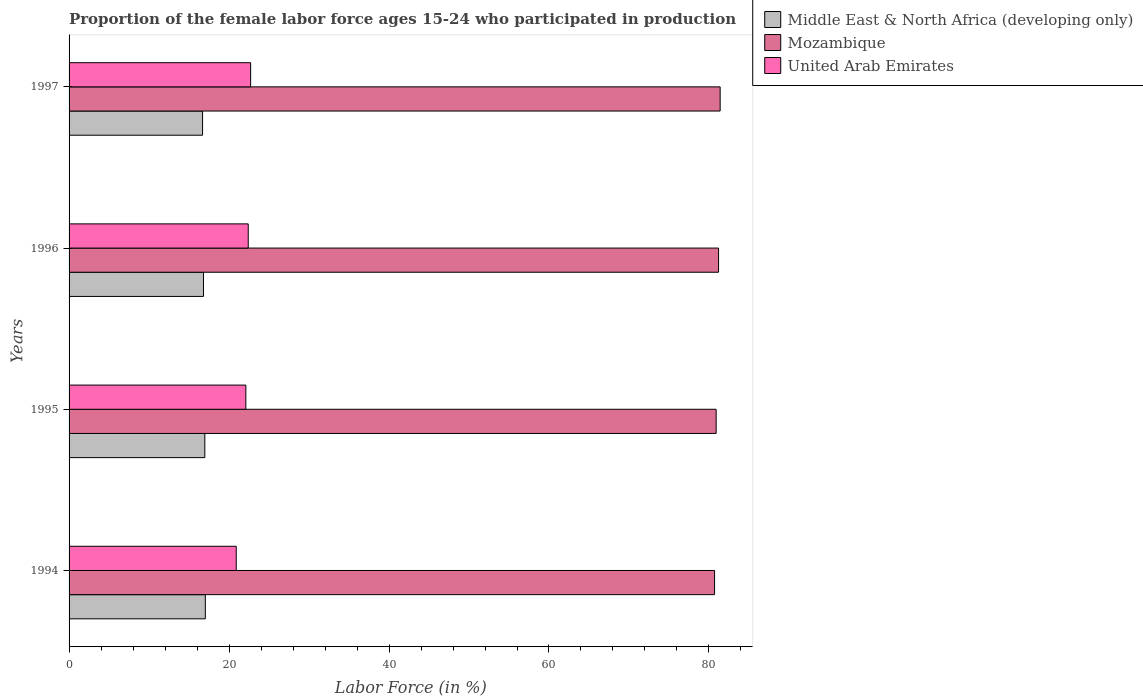How many different coloured bars are there?
Offer a very short reply. 3. How many groups of bars are there?
Ensure brevity in your answer.  4. Are the number of bars per tick equal to the number of legend labels?
Ensure brevity in your answer.  Yes. Are the number of bars on each tick of the Y-axis equal?
Offer a very short reply. Yes. How many bars are there on the 3rd tick from the top?
Offer a very short reply. 3. In how many cases, is the number of bars for a given year not equal to the number of legend labels?
Offer a terse response. 0. What is the proportion of the female labor force who participated in production in United Arab Emirates in 1997?
Offer a terse response. 22.7. Across all years, what is the maximum proportion of the female labor force who participated in production in Mozambique?
Make the answer very short. 81.4. Across all years, what is the minimum proportion of the female labor force who participated in production in United Arab Emirates?
Your answer should be compact. 20.9. In which year was the proportion of the female labor force who participated in production in United Arab Emirates maximum?
Offer a very short reply. 1997. What is the total proportion of the female labor force who participated in production in Middle East & North Africa (developing only) in the graph?
Offer a very short reply. 67.5. What is the difference between the proportion of the female labor force who participated in production in Middle East & North Africa (developing only) in 1994 and that in 1995?
Keep it short and to the point. 0.06. What is the difference between the proportion of the female labor force who participated in production in United Arab Emirates in 1994 and the proportion of the female labor force who participated in production in Middle East & North Africa (developing only) in 1995?
Offer a terse response. 3.93. What is the average proportion of the female labor force who participated in production in Mozambique per year?
Provide a short and direct response. 81.05. In the year 1994, what is the difference between the proportion of the female labor force who participated in production in United Arab Emirates and proportion of the female labor force who participated in production in Middle East & North Africa (developing only)?
Keep it short and to the point. 3.86. In how many years, is the proportion of the female labor force who participated in production in United Arab Emirates greater than 20 %?
Your response must be concise. 4. What is the ratio of the proportion of the female labor force who participated in production in Middle East & North Africa (developing only) in 1995 to that in 1996?
Your answer should be compact. 1.01. Is the difference between the proportion of the female labor force who participated in production in United Arab Emirates in 1994 and 1995 greater than the difference between the proportion of the female labor force who participated in production in Middle East & North Africa (developing only) in 1994 and 1995?
Your response must be concise. No. What is the difference between the highest and the second highest proportion of the female labor force who participated in production in Mozambique?
Give a very brief answer. 0.2. What is the difference between the highest and the lowest proportion of the female labor force who participated in production in Middle East & North Africa (developing only)?
Your response must be concise. 0.35. Is the sum of the proportion of the female labor force who participated in production in Mozambique in 1994 and 1997 greater than the maximum proportion of the female labor force who participated in production in United Arab Emirates across all years?
Provide a short and direct response. Yes. What does the 2nd bar from the top in 1996 represents?
Offer a very short reply. Mozambique. What does the 3rd bar from the bottom in 1995 represents?
Give a very brief answer. United Arab Emirates. Is it the case that in every year, the sum of the proportion of the female labor force who participated in production in United Arab Emirates and proportion of the female labor force who participated in production in Mozambique is greater than the proportion of the female labor force who participated in production in Middle East & North Africa (developing only)?
Provide a short and direct response. Yes. Are all the bars in the graph horizontal?
Keep it short and to the point. Yes. How many years are there in the graph?
Give a very brief answer. 4. How are the legend labels stacked?
Your answer should be very brief. Vertical. What is the title of the graph?
Offer a terse response. Proportion of the female labor force ages 15-24 who participated in production. Does "Congo (Republic)" appear as one of the legend labels in the graph?
Your answer should be very brief. No. What is the label or title of the Y-axis?
Provide a succinct answer. Years. What is the Labor Force (in %) in Middle East & North Africa (developing only) in 1994?
Offer a very short reply. 17.04. What is the Labor Force (in %) in Mozambique in 1994?
Your answer should be compact. 80.7. What is the Labor Force (in %) in United Arab Emirates in 1994?
Provide a succinct answer. 20.9. What is the Labor Force (in %) of Middle East & North Africa (developing only) in 1995?
Offer a terse response. 16.97. What is the Labor Force (in %) of Mozambique in 1995?
Give a very brief answer. 80.9. What is the Labor Force (in %) in United Arab Emirates in 1995?
Give a very brief answer. 22.1. What is the Labor Force (in %) of Middle East & North Africa (developing only) in 1996?
Your response must be concise. 16.81. What is the Labor Force (in %) in Mozambique in 1996?
Make the answer very short. 81.2. What is the Labor Force (in %) of United Arab Emirates in 1996?
Your answer should be compact. 22.4. What is the Labor Force (in %) in Middle East & North Africa (developing only) in 1997?
Offer a very short reply. 16.69. What is the Labor Force (in %) of Mozambique in 1997?
Give a very brief answer. 81.4. What is the Labor Force (in %) in United Arab Emirates in 1997?
Your response must be concise. 22.7. Across all years, what is the maximum Labor Force (in %) in Middle East & North Africa (developing only)?
Offer a terse response. 17.04. Across all years, what is the maximum Labor Force (in %) in Mozambique?
Offer a very short reply. 81.4. Across all years, what is the maximum Labor Force (in %) in United Arab Emirates?
Make the answer very short. 22.7. Across all years, what is the minimum Labor Force (in %) in Middle East & North Africa (developing only)?
Your answer should be very brief. 16.69. Across all years, what is the minimum Labor Force (in %) of Mozambique?
Your response must be concise. 80.7. Across all years, what is the minimum Labor Force (in %) of United Arab Emirates?
Provide a short and direct response. 20.9. What is the total Labor Force (in %) in Middle East & North Africa (developing only) in the graph?
Give a very brief answer. 67.5. What is the total Labor Force (in %) in Mozambique in the graph?
Offer a terse response. 324.2. What is the total Labor Force (in %) of United Arab Emirates in the graph?
Your answer should be very brief. 88.1. What is the difference between the Labor Force (in %) in Middle East & North Africa (developing only) in 1994 and that in 1995?
Give a very brief answer. 0.06. What is the difference between the Labor Force (in %) of United Arab Emirates in 1994 and that in 1995?
Your response must be concise. -1.2. What is the difference between the Labor Force (in %) in Middle East & North Africa (developing only) in 1994 and that in 1996?
Provide a succinct answer. 0.23. What is the difference between the Labor Force (in %) of Mozambique in 1994 and that in 1996?
Your answer should be compact. -0.5. What is the difference between the Labor Force (in %) in Middle East & North Africa (developing only) in 1994 and that in 1997?
Make the answer very short. 0.35. What is the difference between the Labor Force (in %) of Mozambique in 1994 and that in 1997?
Keep it short and to the point. -0.7. What is the difference between the Labor Force (in %) of Middle East & North Africa (developing only) in 1995 and that in 1996?
Your answer should be compact. 0.17. What is the difference between the Labor Force (in %) of Middle East & North Africa (developing only) in 1995 and that in 1997?
Ensure brevity in your answer.  0.28. What is the difference between the Labor Force (in %) in Mozambique in 1995 and that in 1997?
Your answer should be compact. -0.5. What is the difference between the Labor Force (in %) of Middle East & North Africa (developing only) in 1996 and that in 1997?
Provide a short and direct response. 0.11. What is the difference between the Labor Force (in %) of Mozambique in 1996 and that in 1997?
Provide a short and direct response. -0.2. What is the difference between the Labor Force (in %) of United Arab Emirates in 1996 and that in 1997?
Provide a short and direct response. -0.3. What is the difference between the Labor Force (in %) of Middle East & North Africa (developing only) in 1994 and the Labor Force (in %) of Mozambique in 1995?
Keep it short and to the point. -63.86. What is the difference between the Labor Force (in %) in Middle East & North Africa (developing only) in 1994 and the Labor Force (in %) in United Arab Emirates in 1995?
Your response must be concise. -5.06. What is the difference between the Labor Force (in %) in Mozambique in 1994 and the Labor Force (in %) in United Arab Emirates in 1995?
Offer a very short reply. 58.6. What is the difference between the Labor Force (in %) in Middle East & North Africa (developing only) in 1994 and the Labor Force (in %) in Mozambique in 1996?
Provide a succinct answer. -64.16. What is the difference between the Labor Force (in %) in Middle East & North Africa (developing only) in 1994 and the Labor Force (in %) in United Arab Emirates in 1996?
Offer a very short reply. -5.36. What is the difference between the Labor Force (in %) in Mozambique in 1994 and the Labor Force (in %) in United Arab Emirates in 1996?
Provide a succinct answer. 58.3. What is the difference between the Labor Force (in %) in Middle East & North Africa (developing only) in 1994 and the Labor Force (in %) in Mozambique in 1997?
Provide a short and direct response. -64.36. What is the difference between the Labor Force (in %) in Middle East & North Africa (developing only) in 1994 and the Labor Force (in %) in United Arab Emirates in 1997?
Your answer should be very brief. -5.66. What is the difference between the Labor Force (in %) in Middle East & North Africa (developing only) in 1995 and the Labor Force (in %) in Mozambique in 1996?
Your answer should be very brief. -64.23. What is the difference between the Labor Force (in %) of Middle East & North Africa (developing only) in 1995 and the Labor Force (in %) of United Arab Emirates in 1996?
Ensure brevity in your answer.  -5.43. What is the difference between the Labor Force (in %) in Mozambique in 1995 and the Labor Force (in %) in United Arab Emirates in 1996?
Provide a succinct answer. 58.5. What is the difference between the Labor Force (in %) of Middle East & North Africa (developing only) in 1995 and the Labor Force (in %) of Mozambique in 1997?
Offer a very short reply. -64.43. What is the difference between the Labor Force (in %) of Middle East & North Africa (developing only) in 1995 and the Labor Force (in %) of United Arab Emirates in 1997?
Give a very brief answer. -5.73. What is the difference between the Labor Force (in %) of Mozambique in 1995 and the Labor Force (in %) of United Arab Emirates in 1997?
Offer a very short reply. 58.2. What is the difference between the Labor Force (in %) in Middle East & North Africa (developing only) in 1996 and the Labor Force (in %) in Mozambique in 1997?
Your answer should be compact. -64.59. What is the difference between the Labor Force (in %) of Middle East & North Africa (developing only) in 1996 and the Labor Force (in %) of United Arab Emirates in 1997?
Provide a short and direct response. -5.89. What is the difference between the Labor Force (in %) of Mozambique in 1996 and the Labor Force (in %) of United Arab Emirates in 1997?
Your response must be concise. 58.5. What is the average Labor Force (in %) of Middle East & North Africa (developing only) per year?
Your answer should be compact. 16.88. What is the average Labor Force (in %) in Mozambique per year?
Your answer should be very brief. 81.05. What is the average Labor Force (in %) of United Arab Emirates per year?
Give a very brief answer. 22.02. In the year 1994, what is the difference between the Labor Force (in %) of Middle East & North Africa (developing only) and Labor Force (in %) of Mozambique?
Keep it short and to the point. -63.66. In the year 1994, what is the difference between the Labor Force (in %) of Middle East & North Africa (developing only) and Labor Force (in %) of United Arab Emirates?
Your response must be concise. -3.86. In the year 1994, what is the difference between the Labor Force (in %) of Mozambique and Labor Force (in %) of United Arab Emirates?
Your answer should be compact. 59.8. In the year 1995, what is the difference between the Labor Force (in %) in Middle East & North Africa (developing only) and Labor Force (in %) in Mozambique?
Offer a terse response. -63.93. In the year 1995, what is the difference between the Labor Force (in %) of Middle East & North Africa (developing only) and Labor Force (in %) of United Arab Emirates?
Give a very brief answer. -5.13. In the year 1995, what is the difference between the Labor Force (in %) of Mozambique and Labor Force (in %) of United Arab Emirates?
Offer a terse response. 58.8. In the year 1996, what is the difference between the Labor Force (in %) of Middle East & North Africa (developing only) and Labor Force (in %) of Mozambique?
Your answer should be very brief. -64.39. In the year 1996, what is the difference between the Labor Force (in %) of Middle East & North Africa (developing only) and Labor Force (in %) of United Arab Emirates?
Offer a terse response. -5.59. In the year 1996, what is the difference between the Labor Force (in %) of Mozambique and Labor Force (in %) of United Arab Emirates?
Ensure brevity in your answer.  58.8. In the year 1997, what is the difference between the Labor Force (in %) of Middle East & North Africa (developing only) and Labor Force (in %) of Mozambique?
Give a very brief answer. -64.71. In the year 1997, what is the difference between the Labor Force (in %) of Middle East & North Africa (developing only) and Labor Force (in %) of United Arab Emirates?
Provide a succinct answer. -6.01. In the year 1997, what is the difference between the Labor Force (in %) in Mozambique and Labor Force (in %) in United Arab Emirates?
Your answer should be compact. 58.7. What is the ratio of the Labor Force (in %) of Mozambique in 1994 to that in 1995?
Your response must be concise. 1. What is the ratio of the Labor Force (in %) in United Arab Emirates in 1994 to that in 1995?
Provide a short and direct response. 0.95. What is the ratio of the Labor Force (in %) in Middle East & North Africa (developing only) in 1994 to that in 1996?
Give a very brief answer. 1.01. What is the ratio of the Labor Force (in %) in Mozambique in 1994 to that in 1996?
Provide a succinct answer. 0.99. What is the ratio of the Labor Force (in %) of United Arab Emirates in 1994 to that in 1996?
Offer a very short reply. 0.93. What is the ratio of the Labor Force (in %) in Middle East & North Africa (developing only) in 1994 to that in 1997?
Ensure brevity in your answer.  1.02. What is the ratio of the Labor Force (in %) of United Arab Emirates in 1994 to that in 1997?
Make the answer very short. 0.92. What is the ratio of the Labor Force (in %) of Middle East & North Africa (developing only) in 1995 to that in 1996?
Give a very brief answer. 1.01. What is the ratio of the Labor Force (in %) in United Arab Emirates in 1995 to that in 1996?
Your response must be concise. 0.99. What is the ratio of the Labor Force (in %) in United Arab Emirates in 1995 to that in 1997?
Give a very brief answer. 0.97. What is the ratio of the Labor Force (in %) of Middle East & North Africa (developing only) in 1996 to that in 1997?
Offer a very short reply. 1.01. What is the ratio of the Labor Force (in %) of Mozambique in 1996 to that in 1997?
Keep it short and to the point. 1. What is the difference between the highest and the second highest Labor Force (in %) in Middle East & North Africa (developing only)?
Offer a very short reply. 0.06. What is the difference between the highest and the second highest Labor Force (in %) of Mozambique?
Make the answer very short. 0.2. What is the difference between the highest and the second highest Labor Force (in %) in United Arab Emirates?
Make the answer very short. 0.3. What is the difference between the highest and the lowest Labor Force (in %) in Middle East & North Africa (developing only)?
Ensure brevity in your answer.  0.35. What is the difference between the highest and the lowest Labor Force (in %) in Mozambique?
Provide a short and direct response. 0.7. 